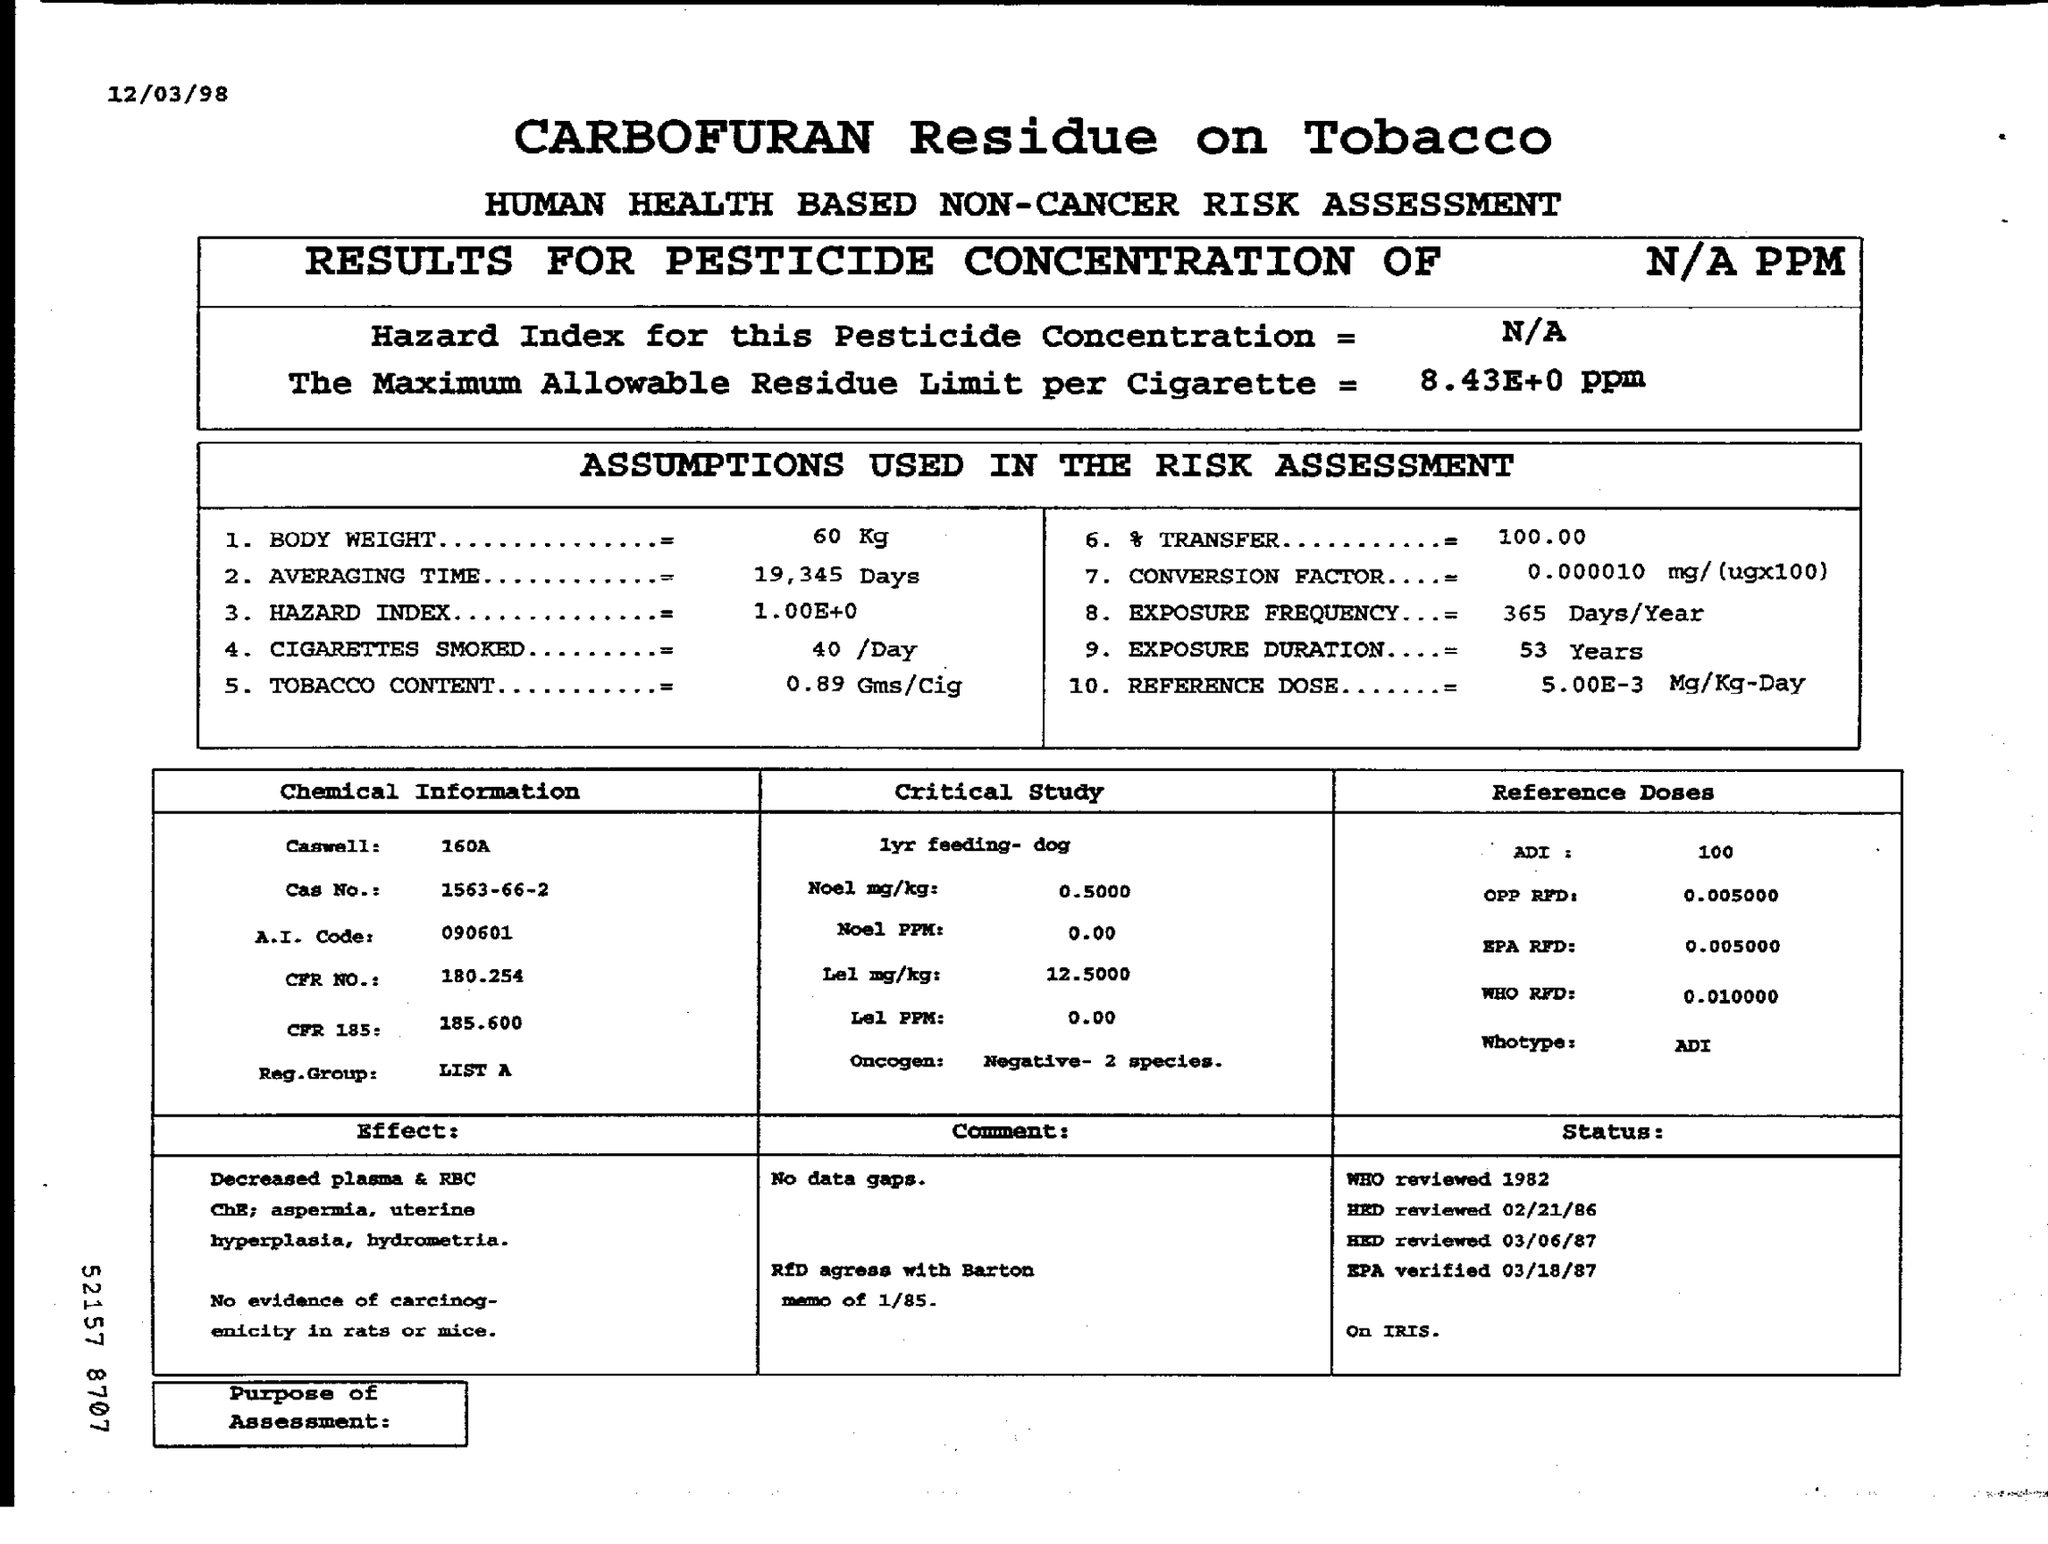Based on the assumptions listed, how are the smoking habits of an individual factored into this risk assessment? The risk assessment takes smoking habits into account by considering the average body weight, number of cigarettes smoked per day (40/day), and the tobacco content per cigarette (0.89 Gms/Cig). These factors help in calculating the likelihood of exposure to Carbofuran through smoking and its potential impact on health. 